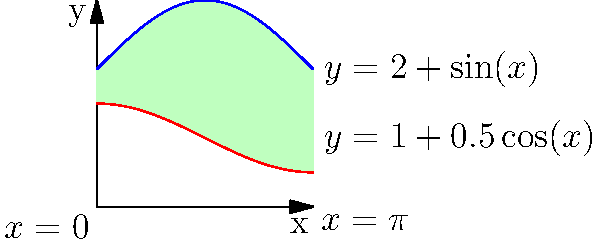As part of an urban development project, you need to calculate the area of an irregularly shaped land plot. The plot is bounded by two curves: $y = 2 + \sin(x)$ on top and $y = 1 + 0.5\cos(x)$ on the bottom, from $x = 0$ to $x = \pi$. Calculate the area of this land plot using integration. To find the area between two curves, we need to integrate the difference between the upper and lower functions over the given interval. Here's how we proceed:

1) The area is given by the formula:
   $$A = \int_a^b [f(x) - g(x)] dx$$
   where $f(x)$ is the upper function and $g(x)$ is the lower function.

2) In this case:
   $f(x) = 2 + \sin(x)$
   $g(x) = 1 + 0.5\cos(x)$
   $a = 0$, $b = \pi$

3) Substituting into the formula:
   $$A = \int_0^\pi [(2 + \sin(x)) - (1 + 0.5\cos(x))] dx$$

4) Simplifying the integrand:
   $$A = \int_0^\pi [1 + \sin(x) - 0.5\cos(x)] dx$$

5) Integrating term by term:
   $$A = [x - \cos(x) + 0.5\sin(x)]_0^\pi$$

6) Evaluating the antiderivative at the limits:
   $$A = [\pi - \cos(\pi) + 0.5\sin(\pi)] - [0 - \cos(0) + 0.5\sin(0)]$$

7) Simplifying:
   $$A = \pi - (-1) + 0 - [0 - 1 + 0]$$
   $$A = \pi + 1 + 1 = \pi + 2$$

Therefore, the area of the land plot is $\pi + 2$ square units.
Answer: $\pi + 2$ square units 